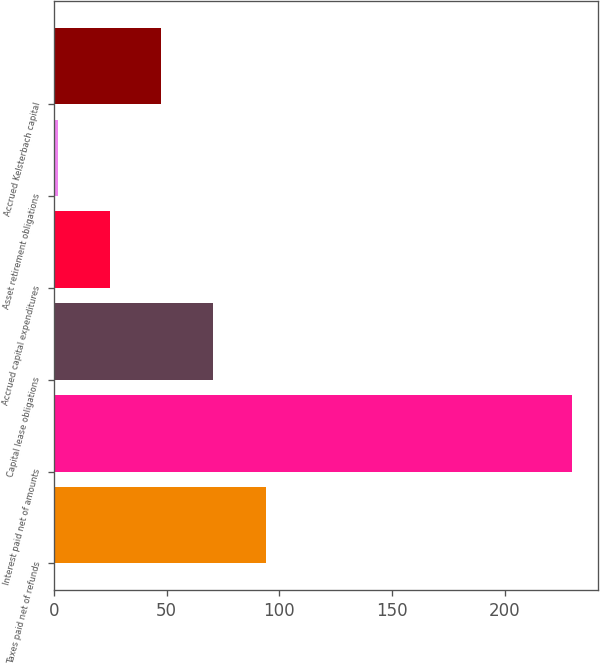Convert chart to OTSL. <chart><loc_0><loc_0><loc_500><loc_500><bar_chart><fcel>Taxes paid net of refunds<fcel>Interest paid net of amounts<fcel>Capital lease obligations<fcel>Accrued capital expenditures<fcel>Asset retirement obligations<fcel>Accrued Kelsterbach capital<nl><fcel>94<fcel>230<fcel>70.4<fcel>24.8<fcel>2<fcel>47.6<nl></chart> 